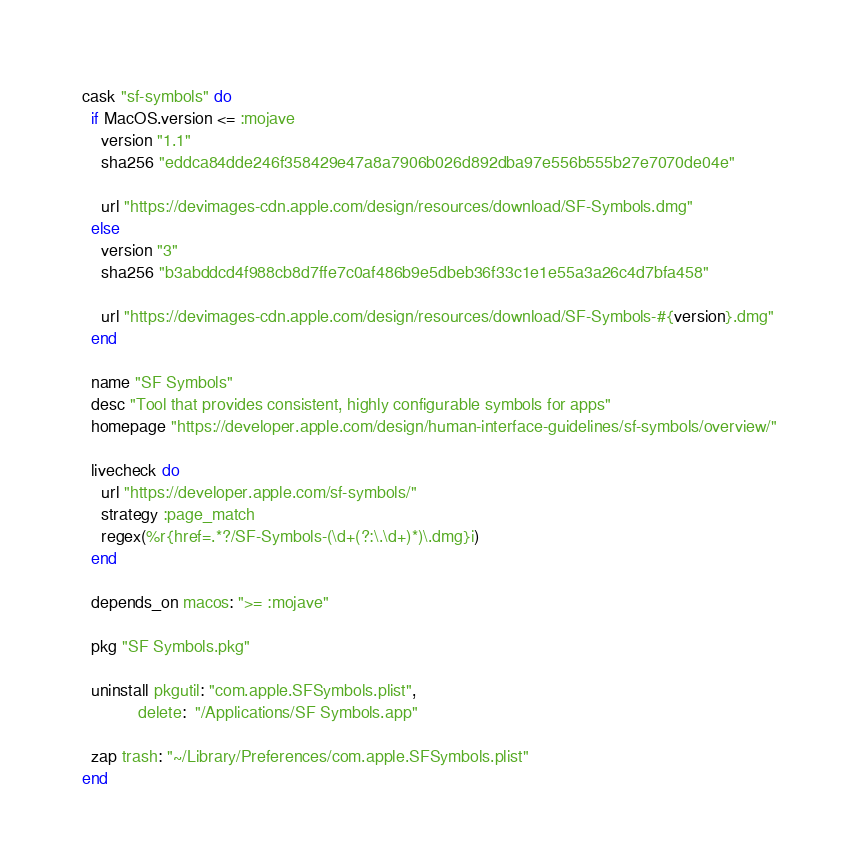Convert code to text. <code><loc_0><loc_0><loc_500><loc_500><_Ruby_>cask "sf-symbols" do
  if MacOS.version <= :mojave
    version "1.1"
    sha256 "eddca84dde246f358429e47a8a7906b026d892dba97e556b555b27e7070de04e"

    url "https://devimages-cdn.apple.com/design/resources/download/SF-Symbols.dmg"
  else
    version "3"
    sha256 "b3abddcd4f988cb8d7ffe7c0af486b9e5dbeb36f33c1e1e55a3a26c4d7bfa458"

    url "https://devimages-cdn.apple.com/design/resources/download/SF-Symbols-#{version}.dmg"
  end

  name "SF Symbols"
  desc "Tool that provides consistent, highly configurable symbols for apps"
  homepage "https://developer.apple.com/design/human-interface-guidelines/sf-symbols/overview/"

  livecheck do
    url "https://developer.apple.com/sf-symbols/"
    strategy :page_match
    regex(%r{href=.*?/SF-Symbols-(\d+(?:\.\d+)*)\.dmg}i)
  end

  depends_on macos: ">= :mojave"

  pkg "SF Symbols.pkg"

  uninstall pkgutil: "com.apple.SFSymbols.plist",
            delete:  "/Applications/SF Symbols.app"

  zap trash: "~/Library/Preferences/com.apple.SFSymbols.plist"
end
</code> 